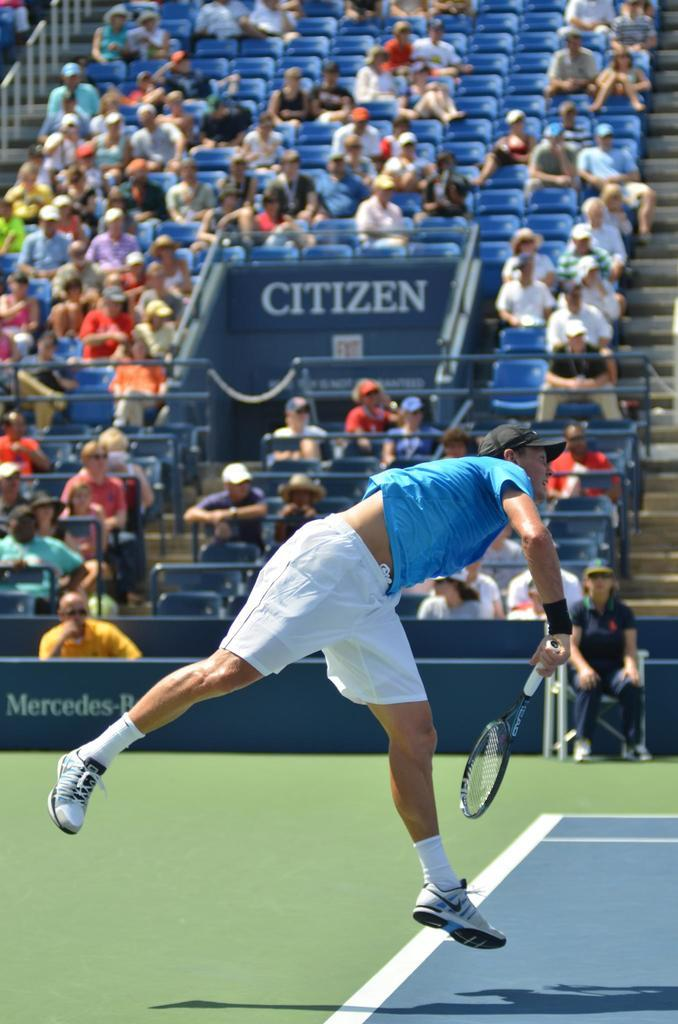What are the people in the background of the image doing? The people in the background of the image are sitting on chairs. What is the man in the foreground wearing on his upper body? The man is wearing a blue t-shirt. What type of headwear is the man wearing? The man is wearing a black cap. What accessory is the man wearing on his wrist? The man is wearing a wristband. What activity does it seem like the man is engaged in? The man appears to be playing badminton in the air. Can you tell me how many boats are visible in the image? There are no boats present in the image. What type of knee injury does the man have in the image? There is no indication of a knee injury in the image; the man appears to be playing badminton without any visible issues. 